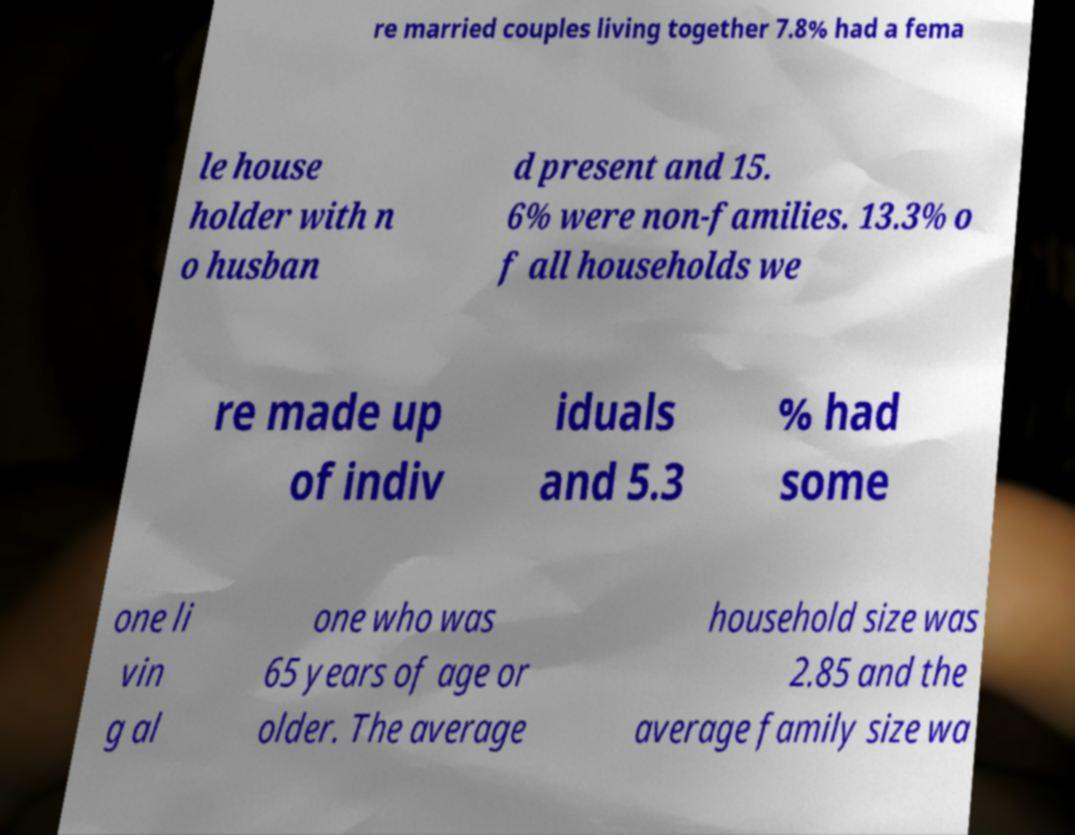For documentation purposes, I need the text within this image transcribed. Could you provide that? re married couples living together 7.8% had a fema le house holder with n o husban d present and 15. 6% were non-families. 13.3% o f all households we re made up of indiv iduals and 5.3 % had some one li vin g al one who was 65 years of age or older. The average household size was 2.85 and the average family size wa 